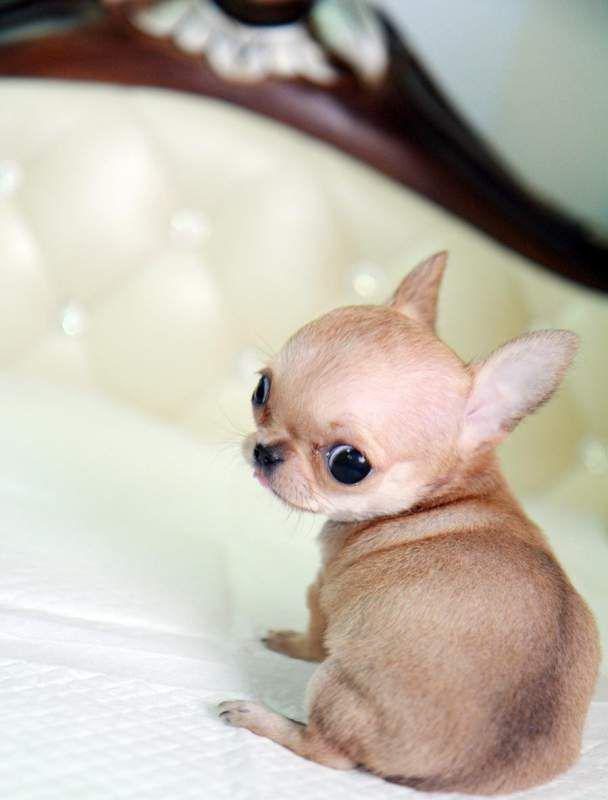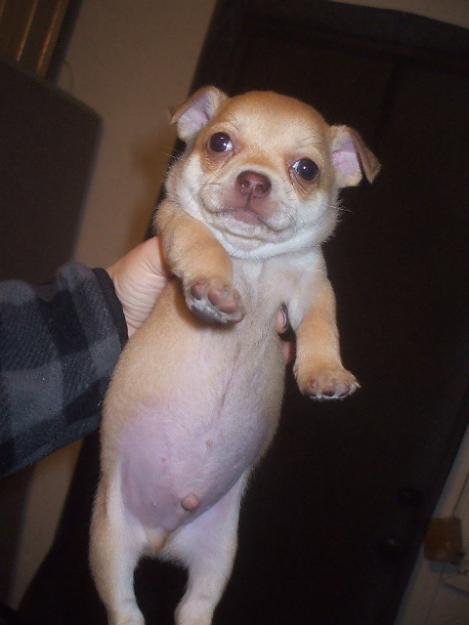The first image is the image on the left, the second image is the image on the right. Considering the images on both sides, is "Each image shows one teacup puppy displayed on a human hand, and the puppy on the right is solid white." valid? Answer yes or no. No. The first image is the image on the left, the second image is the image on the right. Evaluate the accuracy of this statement regarding the images: "Both images show one small dog in a person's hand". Is it true? Answer yes or no. No. 